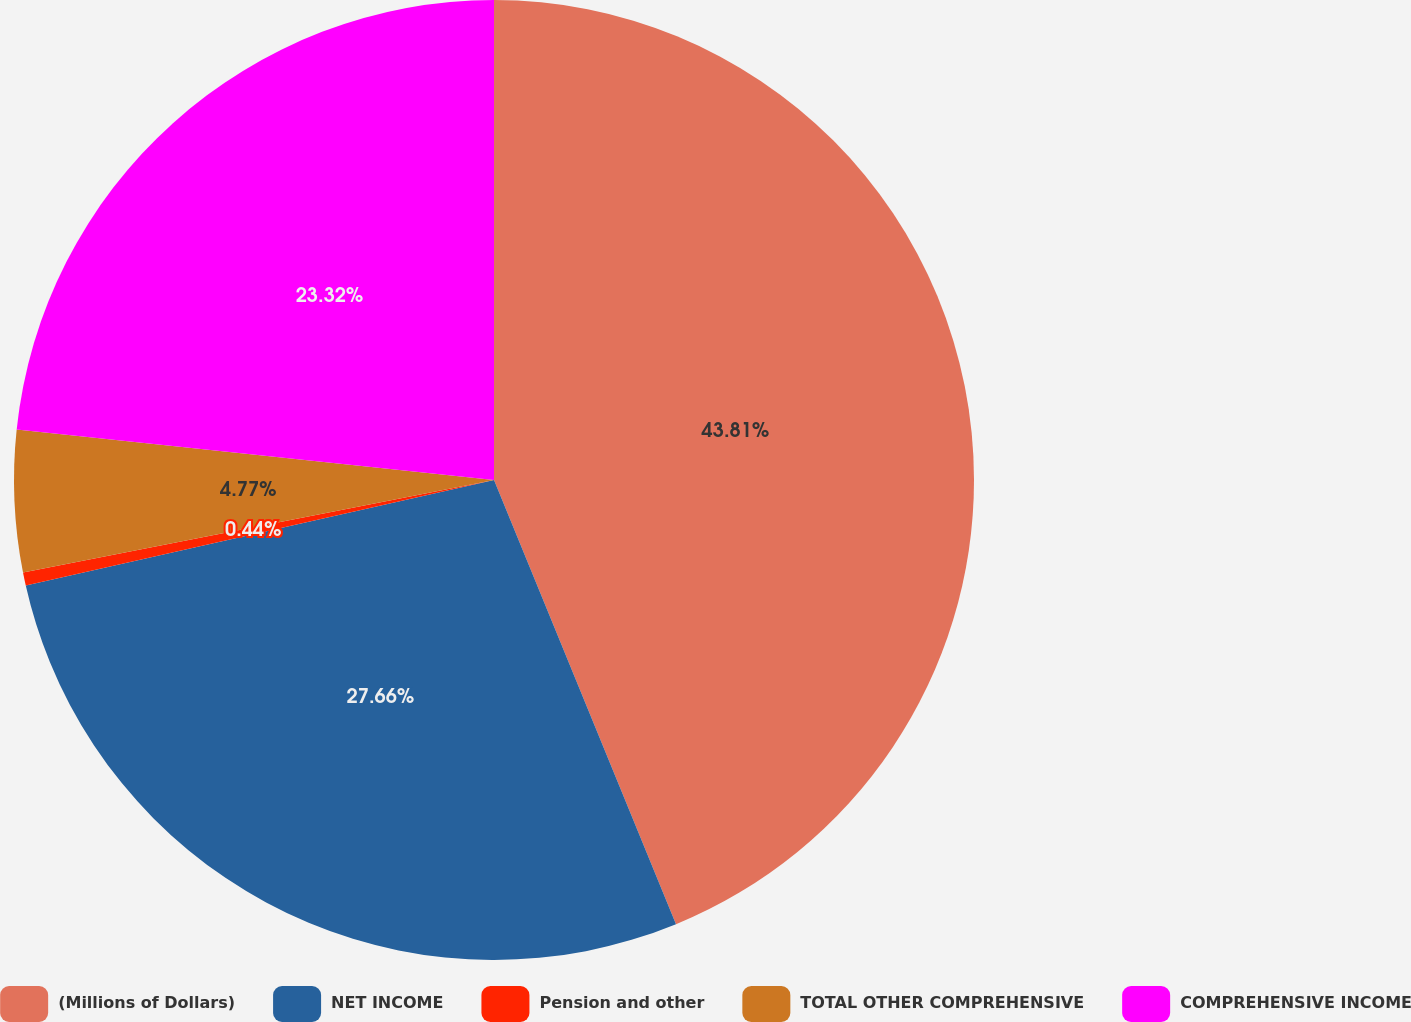Convert chart. <chart><loc_0><loc_0><loc_500><loc_500><pie_chart><fcel>(Millions of Dollars)<fcel>NET INCOME<fcel>Pension and other<fcel>TOTAL OTHER COMPREHENSIVE<fcel>COMPREHENSIVE INCOME<nl><fcel>43.81%<fcel>27.66%<fcel>0.44%<fcel>4.77%<fcel>23.32%<nl></chart> 